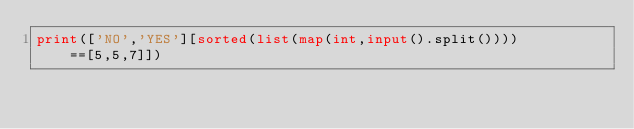Convert code to text. <code><loc_0><loc_0><loc_500><loc_500><_Python_>print(['NO','YES'][sorted(list(map(int,input().split())))==[5,5,7]])</code> 